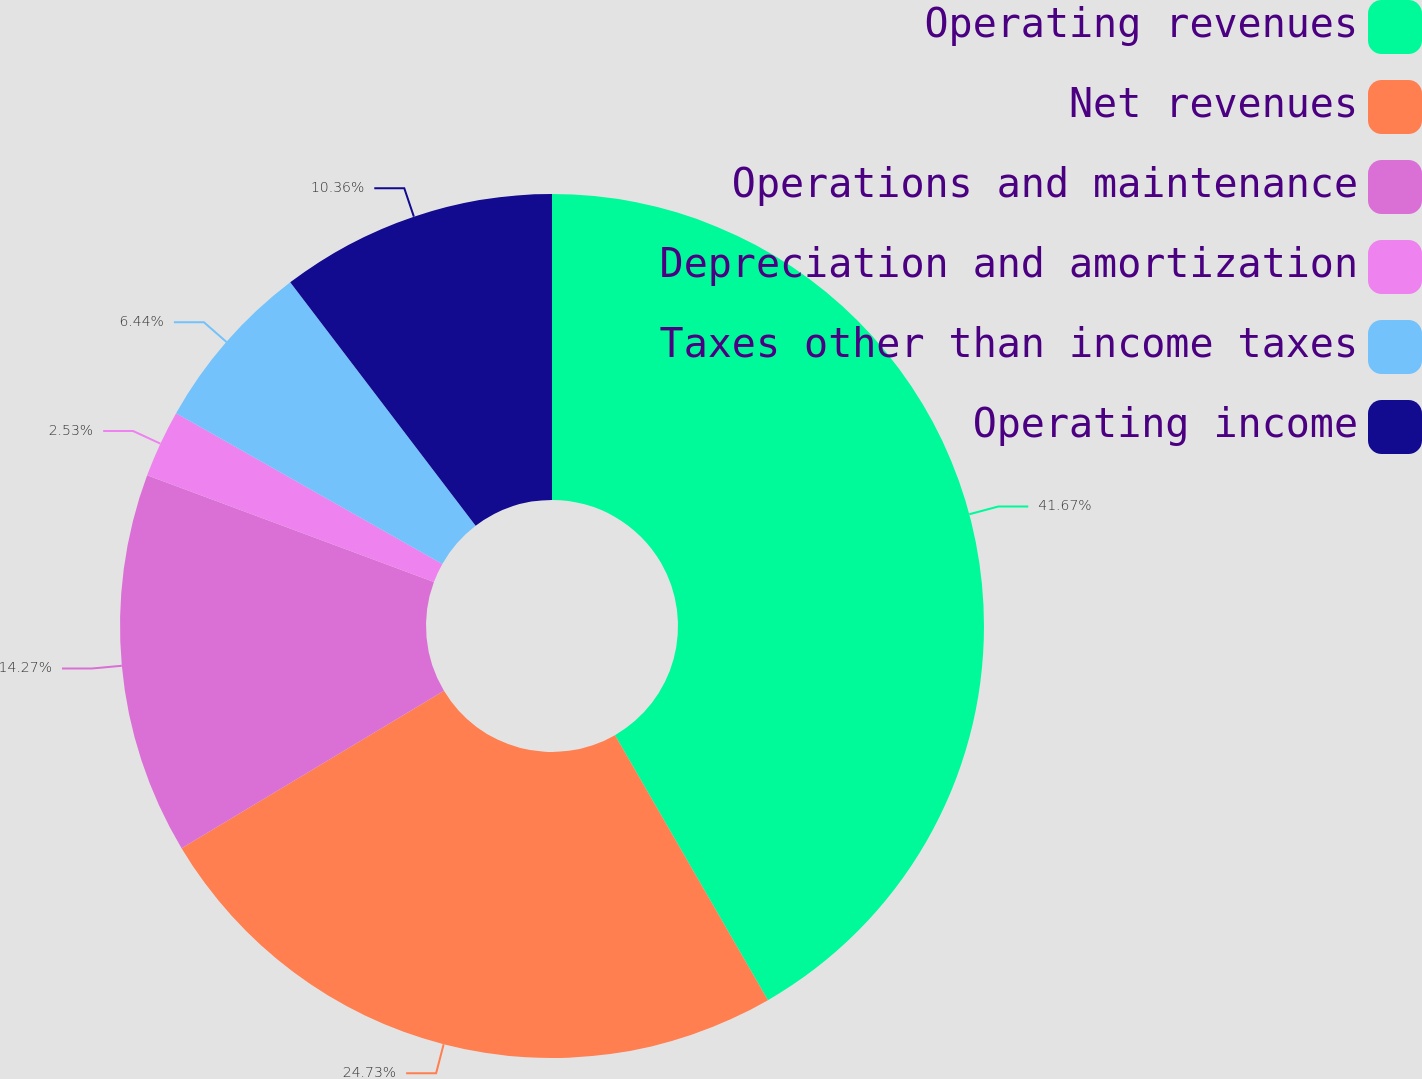<chart> <loc_0><loc_0><loc_500><loc_500><pie_chart><fcel>Operating revenues<fcel>Net revenues<fcel>Operations and maintenance<fcel>Depreciation and amortization<fcel>Taxes other than income taxes<fcel>Operating income<nl><fcel>41.67%<fcel>24.73%<fcel>14.27%<fcel>2.53%<fcel>6.44%<fcel>10.36%<nl></chart> 